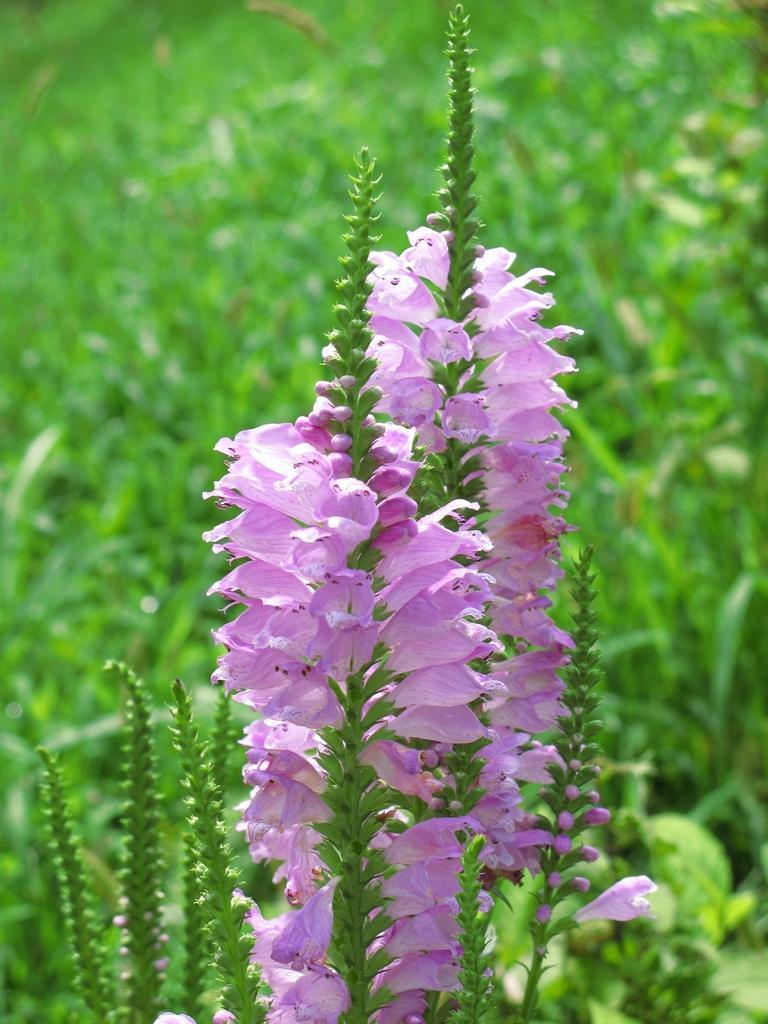In one or two sentences, can you explain what this image depicts? In this image I can see many plants. In the foreground there are few stems along with the flowers and buds. 